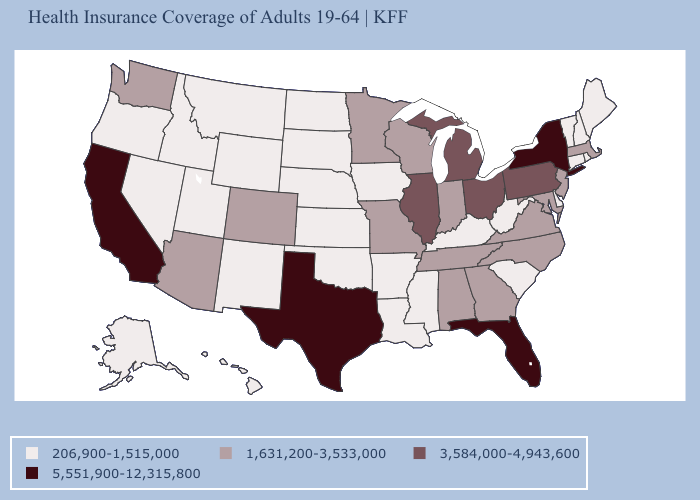Name the states that have a value in the range 5,551,900-12,315,800?
Answer briefly. California, Florida, New York, Texas. What is the highest value in the Northeast ?
Concise answer only. 5,551,900-12,315,800. Is the legend a continuous bar?
Keep it brief. No. What is the value of Rhode Island?
Quick response, please. 206,900-1,515,000. Does the map have missing data?
Answer briefly. No. What is the value of Wyoming?
Concise answer only. 206,900-1,515,000. What is the lowest value in the USA?
Short answer required. 206,900-1,515,000. What is the highest value in the USA?
Quick response, please. 5,551,900-12,315,800. Name the states that have a value in the range 3,584,000-4,943,600?
Be succinct. Illinois, Michigan, Ohio, Pennsylvania. Name the states that have a value in the range 206,900-1,515,000?
Give a very brief answer. Alaska, Arkansas, Connecticut, Delaware, Hawaii, Idaho, Iowa, Kansas, Kentucky, Louisiana, Maine, Mississippi, Montana, Nebraska, Nevada, New Hampshire, New Mexico, North Dakota, Oklahoma, Oregon, Rhode Island, South Carolina, South Dakota, Utah, Vermont, West Virginia, Wyoming. What is the lowest value in the USA?
Write a very short answer. 206,900-1,515,000. Which states have the lowest value in the USA?
Write a very short answer. Alaska, Arkansas, Connecticut, Delaware, Hawaii, Idaho, Iowa, Kansas, Kentucky, Louisiana, Maine, Mississippi, Montana, Nebraska, Nevada, New Hampshire, New Mexico, North Dakota, Oklahoma, Oregon, Rhode Island, South Carolina, South Dakota, Utah, Vermont, West Virginia, Wyoming. Does the first symbol in the legend represent the smallest category?
Answer briefly. Yes. Is the legend a continuous bar?
Quick response, please. No. What is the value of Oregon?
Quick response, please. 206,900-1,515,000. 